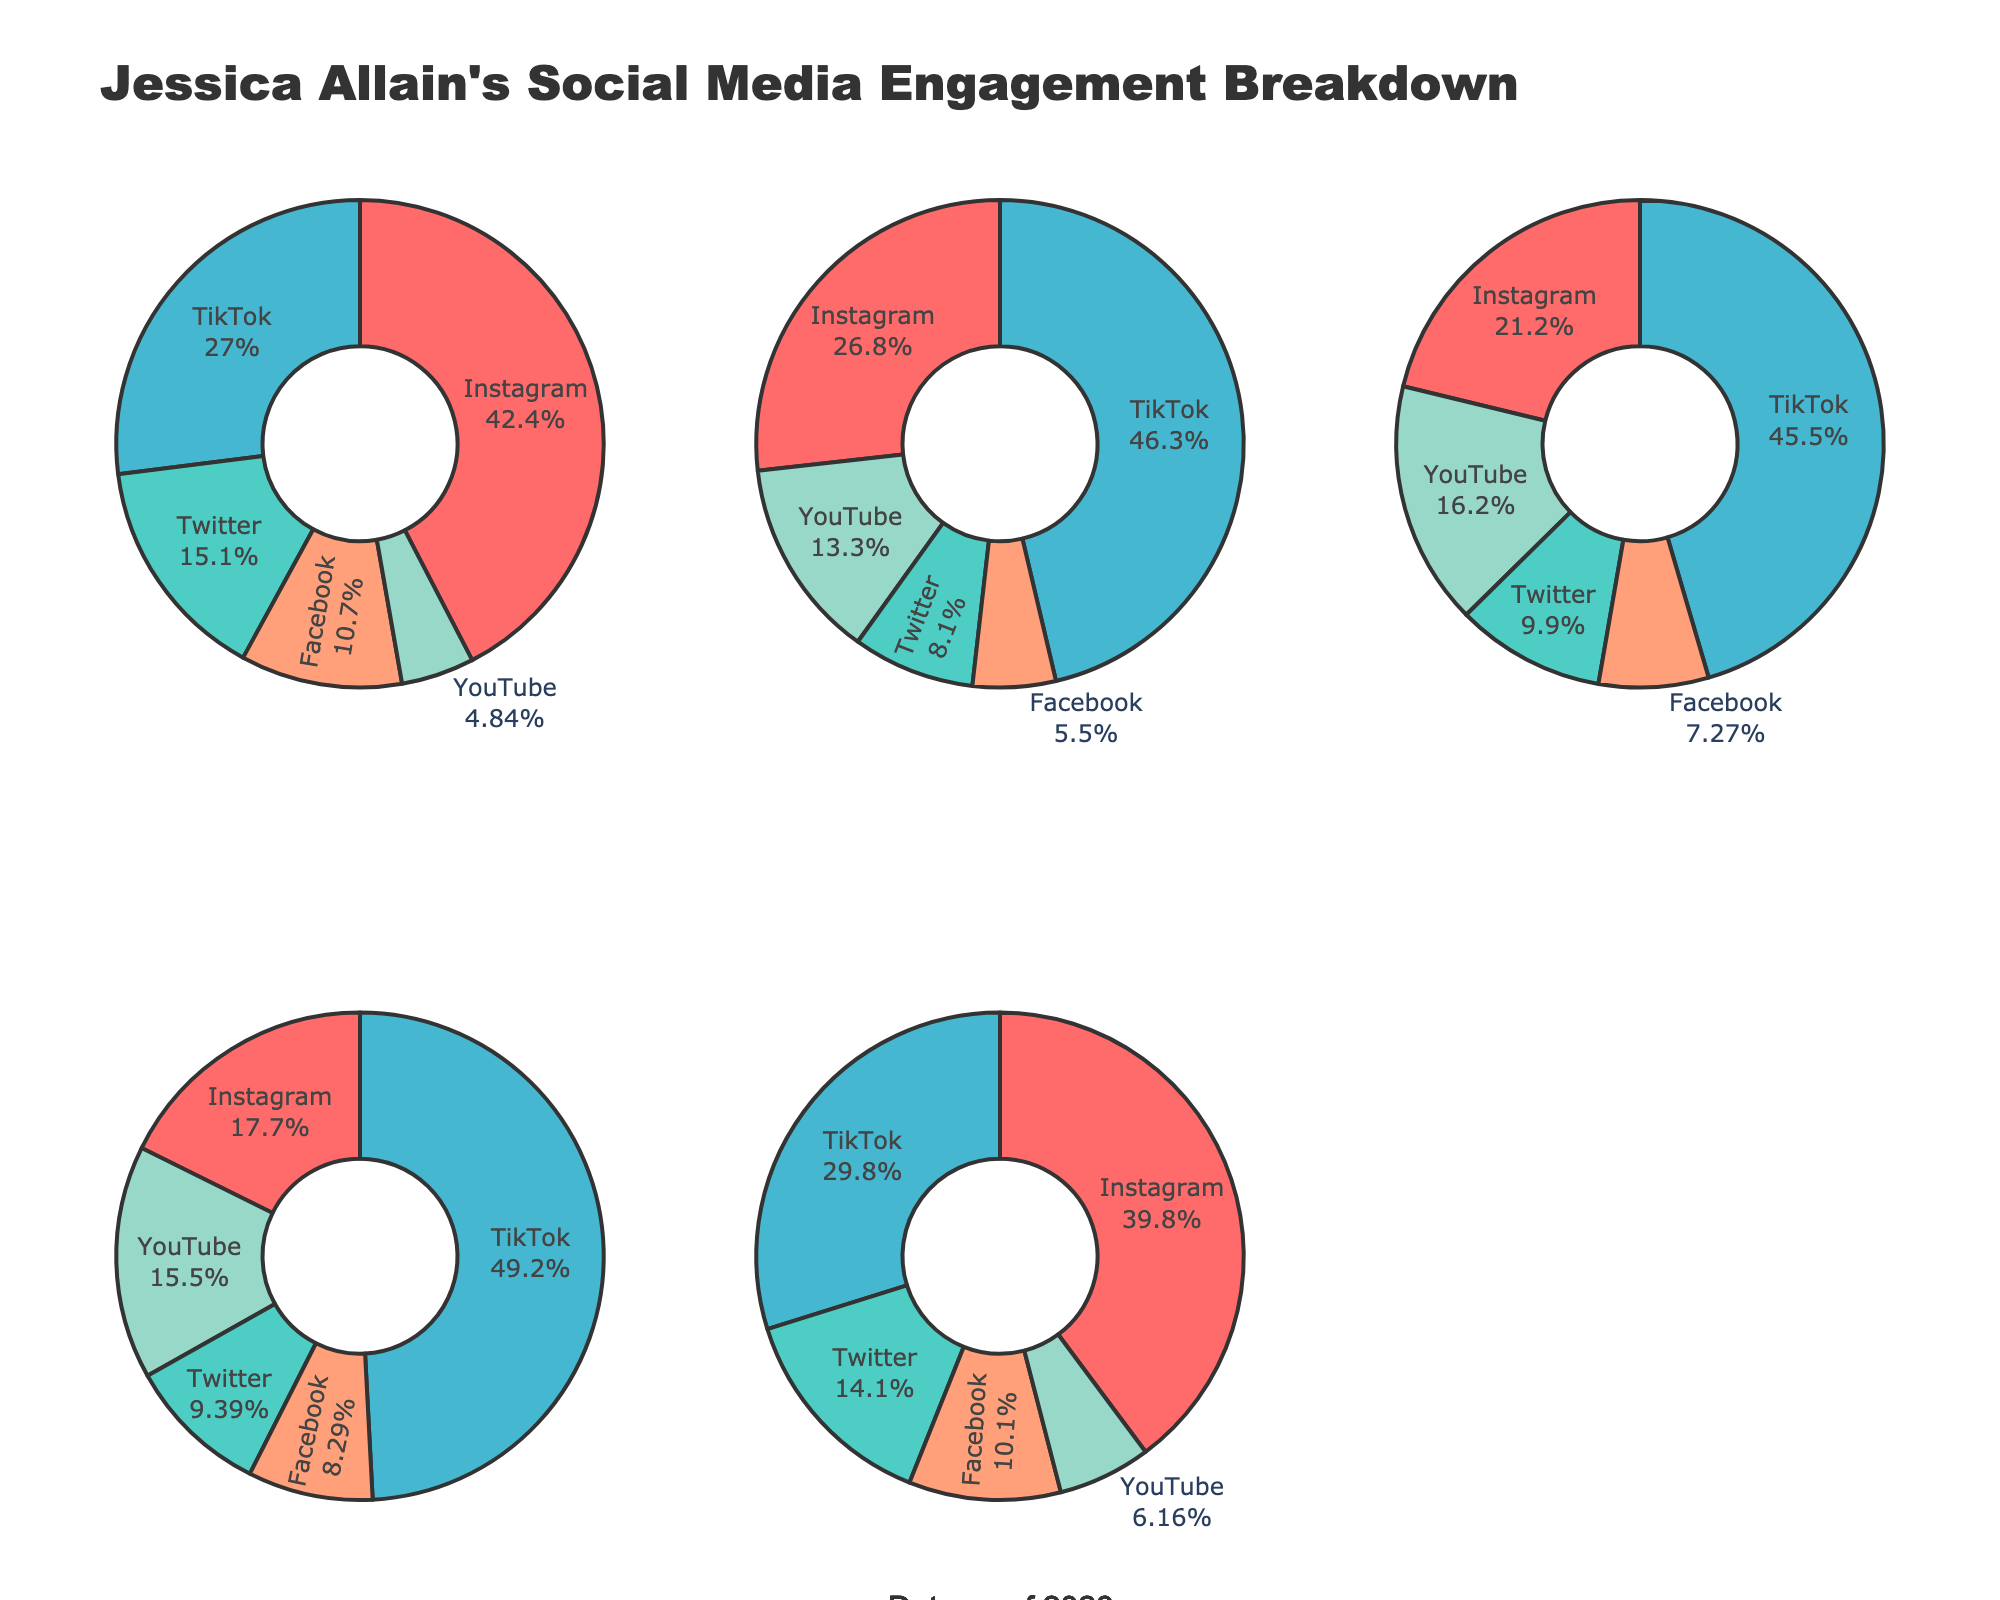What is the title of the figure? The title of the figure is displayed at the top and summarizes the overall content. It mentions both media coverage intensity and public opinion shifts in international disputes.
Answer: Media Coverage Intensity vs Public Opinion Shifts in International Disputes Which dispute has the highest media coverage intensity? To find the highest media coverage intensity, look at the left subplot and identify the point farthest to the right. That dispute is the Russian-Ukrainian War with an intensity of 95.
Answer: Russian-Ukrainian War What is the range of public opinion shifts displayed in the figure? The X-axis of the right subplot shows public opinion shifts, with the minimum (Yemen Civil War) at 3 and the maximum (Russian-Ukrainian War) at 22. Subtracting the smallest value from the largest gives us the range. So, the range is 22 - 3 = 19.
Answer: 19 Which dispute shows the least public opinion shift? On the right subplot, look for the marker at the lowest position on the X-axis. The Yemen Civil War has the least public opinion shift with a value of 3.
Answer: Yemen Civil War How many disputes have a media coverage intensity above 80? By examining the data points in the left subplot, count the number of disputes positioned right of the 80 mark on the X-axis. Those are the Israeli-Palestinian Conflict, Russian-Ukrainian War, Brexit, and North Korea Nuclear Crisis, totaling four disputes.
Answer: 4 Is there a noticeable pattern between media coverage intensity and public opinion shifts? Comparing the two subplots, observe if disputes with high media coverage also show high public opinion shifts. The Russian-Ukrainian War, which has the maximum media coverage, also shows a significant opinion shift, indicating a possible positive correlation.
Answer: Yes, there is a pattern Which dispute has a similar media coverage intensity but a higher public opinion shift than the US-China Trade War? The US-China Trade War has a media coverage intensity of 76 and a public opinion shift of 9. Looking for a dispute with a similar intensity but higher shift, the Brexit dispute fits with an intensity of 82 and a shift of 18.
Answer: Brexit What are the media coverage intensity and public opinion shift for the Venezuelan Political Crisis? Locate the Venezuelan Political Crisis on both subplots. The left subplot shows a media coverage intensity of 52, and the right subplot indicates a public opinion shift of 4.
Answer: 52 and 4 